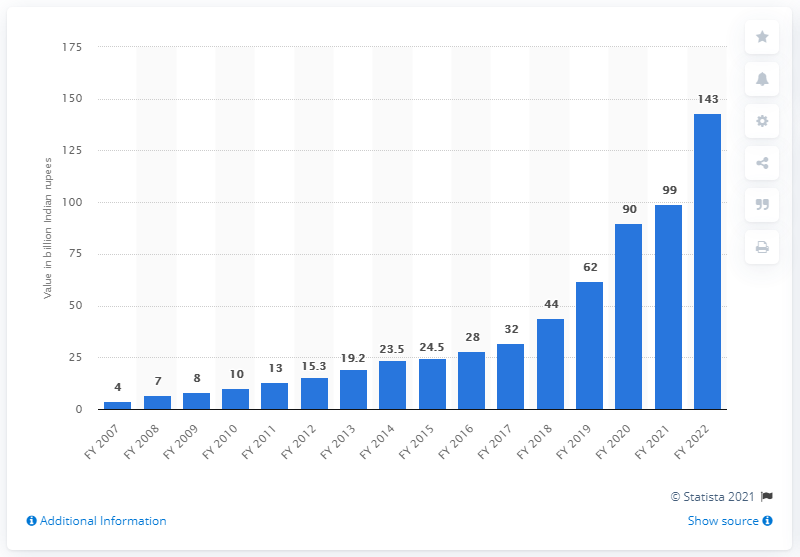Identify some key points in this picture. The market value of India's gaming industry in financial year 2020 was approximately 90. The market value of India's gaming industry in 2022 was 143. 